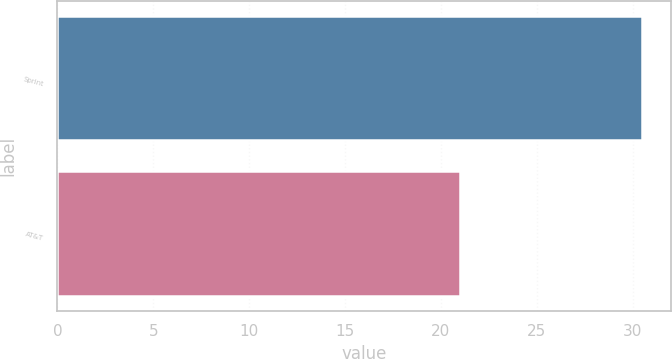Convert chart to OTSL. <chart><loc_0><loc_0><loc_500><loc_500><bar_chart><fcel>Sprint<fcel>AT&T<nl><fcel>30.5<fcel>21<nl></chart> 